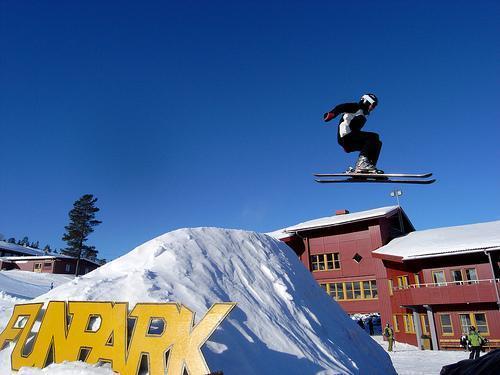How many skis are there?
Give a very brief answer. 2. 